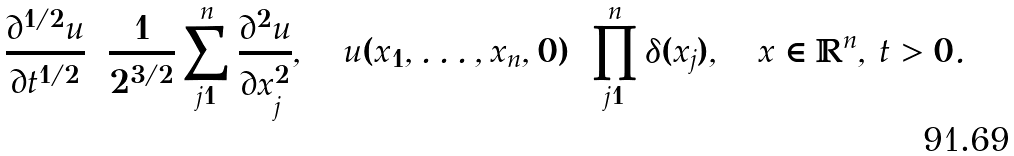<formula> <loc_0><loc_0><loc_500><loc_500>\frac { \partial ^ { 1 / 2 } u } { \partial t ^ { 1 / 2 } } = \frac { 1 } { 2 ^ { 3 / 2 } } \sum _ { j = 1 } ^ { n } \frac { \partial ^ { 2 } u } { \partial x ^ { 2 } _ { j } } , \quad u ( x _ { 1 } , \dots , x _ { n } , 0 ) = \prod _ { j = 1 } ^ { n } \delta ( x _ { j } ) , \quad x \in \mathbb { R } ^ { n } , \, t > 0 .</formula> 